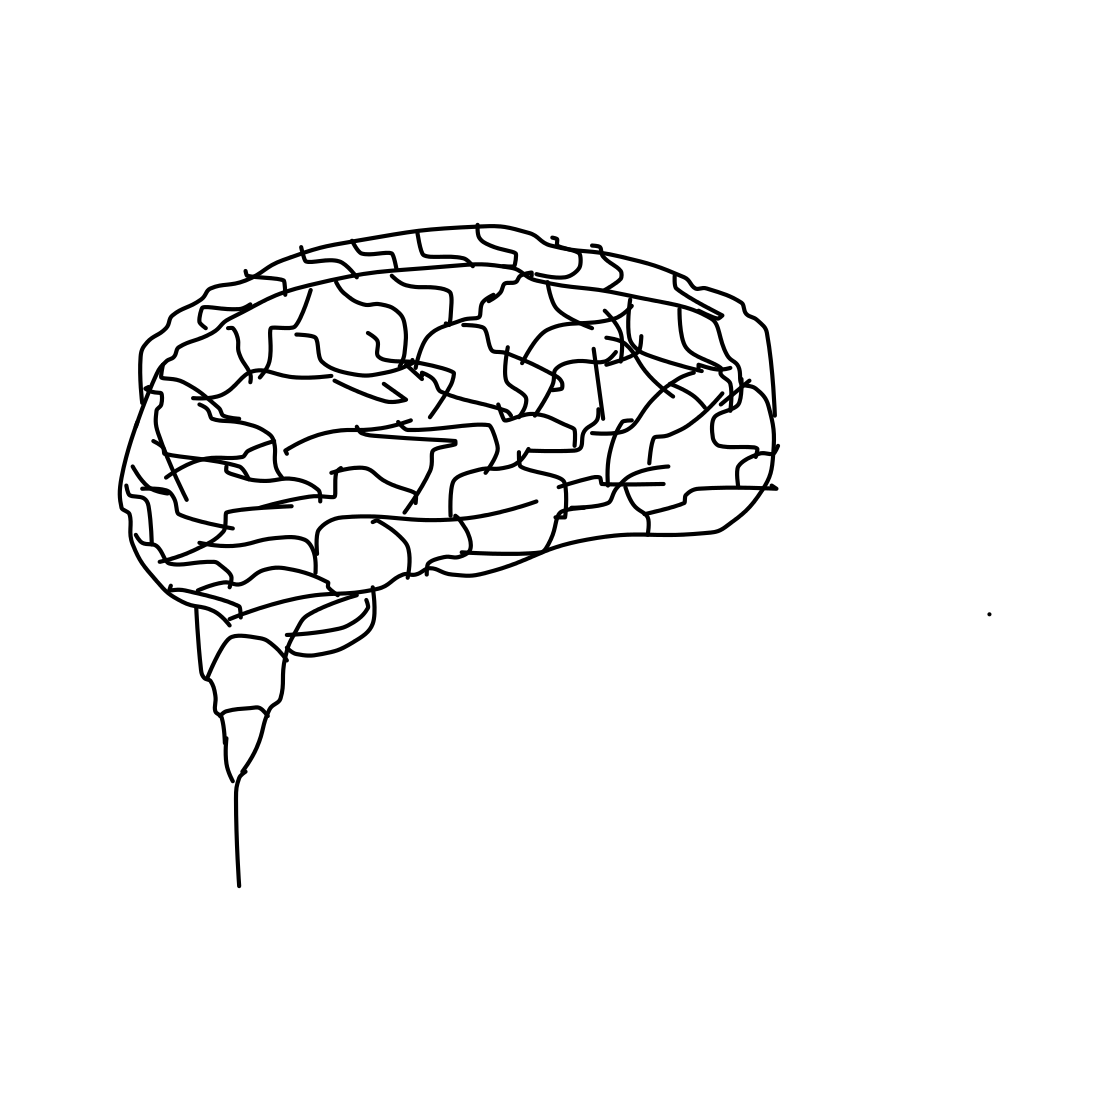How might this image be used in an educational setting? This type of image could be used to help students visualize and understand the basic structure and organization of the brain. It could serve as an introductory tool in subjects like biology, psychology, or neuroscience. Can you explain why understanding the structure of the brain is important? Understanding the structure of the brain is crucial because it helps in grasping how different brain areas contribute to various functions such as thinking, emotion, and motor control. This knowledge is foundational in neuroscience and can aid in better understanding human behavior and treating neurological disorders. 